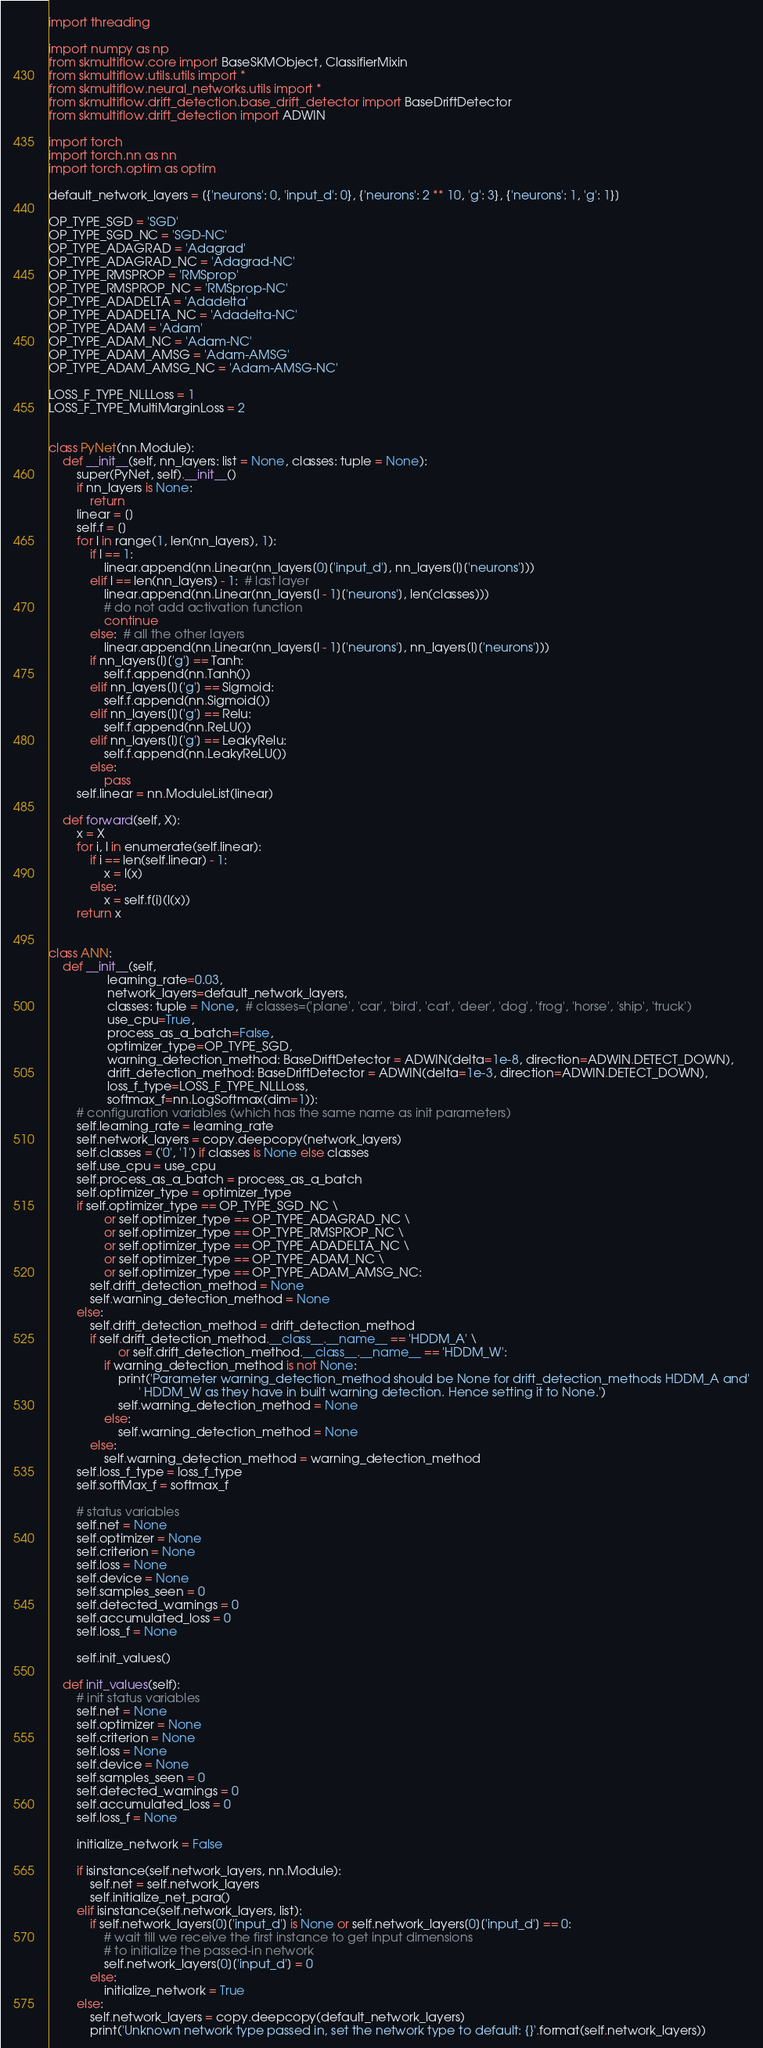Convert code to text. <code><loc_0><loc_0><loc_500><loc_500><_Python_>import threading

import numpy as np
from skmultiflow.core import BaseSKMObject, ClassifierMixin
from skmultiflow.utils.utils import *
from skmultiflow.neural_networks.utils import *
from skmultiflow.drift_detection.base_drift_detector import BaseDriftDetector
from skmultiflow.drift_detection import ADWIN

import torch
import torch.nn as nn
import torch.optim as optim

default_network_layers = [{'neurons': 0, 'input_d': 0}, {'neurons': 2 ** 10, 'g': 3}, {'neurons': 1, 'g': 1}]

OP_TYPE_SGD = 'SGD'
OP_TYPE_SGD_NC = 'SGD-NC'
OP_TYPE_ADAGRAD = 'Adagrad'
OP_TYPE_ADAGRAD_NC = 'Adagrad-NC'
OP_TYPE_RMSPROP = 'RMSprop'
OP_TYPE_RMSPROP_NC = 'RMSprop-NC'
OP_TYPE_ADADELTA = 'Adadelta'
OP_TYPE_ADADELTA_NC = 'Adadelta-NC'
OP_TYPE_ADAM = 'Adam'
OP_TYPE_ADAM_NC = 'Adam-NC'
OP_TYPE_ADAM_AMSG = 'Adam-AMSG'
OP_TYPE_ADAM_AMSG_NC = 'Adam-AMSG-NC'

LOSS_F_TYPE_NLLLoss = 1
LOSS_F_TYPE_MultiMarginLoss = 2


class PyNet(nn.Module):
    def __init__(self, nn_layers: list = None, classes: tuple = None):
        super(PyNet, self).__init__()
        if nn_layers is None:
            return
        linear = []
        self.f = []
        for l in range(1, len(nn_layers), 1):
            if l == 1:
                linear.append(nn.Linear(nn_layers[0]['input_d'], nn_layers[l]['neurons']))
            elif l == len(nn_layers) - 1:  # last layer
                linear.append(nn.Linear(nn_layers[l - 1]['neurons'], len(classes)))
                # do not add activation function
                continue
            else:  # all the other layers
                linear.append(nn.Linear(nn_layers[l - 1]['neurons'], nn_layers[l]['neurons']))
            if nn_layers[l]['g'] == Tanh:
                self.f.append(nn.Tanh())
            elif nn_layers[l]['g'] == Sigmoid:
                self.f.append(nn.Sigmoid())
            elif nn_layers[l]['g'] == Relu:
                self.f.append(nn.ReLU())
            elif nn_layers[l]['g'] == LeakyRelu:
                self.f.append(nn.LeakyReLU())
            else:
                pass
        self.linear = nn.ModuleList(linear)

    def forward(self, X):
        x = X
        for i, l in enumerate(self.linear):
            if i == len(self.linear) - 1:
                x = l(x)
            else:
                x = self.f[i](l(x))
        return x


class ANN:
    def __init__(self,
                 learning_rate=0.03,
                 network_layers=default_network_layers,
                 classes: tuple = None,  # classes=('plane', 'car', 'bird', 'cat', 'deer', 'dog', 'frog', 'horse', 'ship', 'truck')
                 use_cpu=True,
                 process_as_a_batch=False,
                 optimizer_type=OP_TYPE_SGD,
                 warning_detection_method: BaseDriftDetector = ADWIN(delta=1e-8, direction=ADWIN.DETECT_DOWN),
                 drift_detection_method: BaseDriftDetector = ADWIN(delta=1e-3, direction=ADWIN.DETECT_DOWN),
                 loss_f_type=LOSS_F_TYPE_NLLLoss,
                 softmax_f=nn.LogSoftmax(dim=1)):
        # configuration variables (which has the same name as init parameters)
        self.learning_rate = learning_rate
        self.network_layers = copy.deepcopy(network_layers)
        self.classes = ('0', '1') if classes is None else classes
        self.use_cpu = use_cpu
        self.process_as_a_batch = process_as_a_batch
        self.optimizer_type = optimizer_type
        if self.optimizer_type == OP_TYPE_SGD_NC \
                or self.optimizer_type == OP_TYPE_ADAGRAD_NC \
                or self.optimizer_type == OP_TYPE_RMSPROP_NC \
                or self.optimizer_type == OP_TYPE_ADADELTA_NC \
                or self.optimizer_type == OP_TYPE_ADAM_NC \
                or self.optimizer_type == OP_TYPE_ADAM_AMSG_NC:
            self.drift_detection_method = None
            self.warning_detection_method = None
        else:
            self.drift_detection_method = drift_detection_method
            if self.drift_detection_method.__class__.__name__ == 'HDDM_A' \
                    or self.drift_detection_method.__class__.__name__ == 'HDDM_W':
                if warning_detection_method is not None:
                    print('Parameter warning_detection_method should be None for drift_detection_methods HDDM_A and'
                          ' HDDM_W as they have in built warning detection. Hence setting it to None.')
                    self.warning_detection_method = None
                else:
                    self.warning_detection_method = None
            else:
                self.warning_detection_method = warning_detection_method
        self.loss_f_type = loss_f_type
        self.softMax_f = softmax_f

        # status variables
        self.net = None
        self.optimizer = None
        self.criterion = None
        self.loss = None
        self.device = None
        self.samples_seen = 0
        self.detected_warnings = 0
        self.accumulated_loss = 0
        self.loss_f = None

        self.init_values()

    def init_values(self):
        # init status variables
        self.net = None
        self.optimizer = None
        self.criterion = None
        self.loss = None
        self.device = None
        self.samples_seen = 0
        self.detected_warnings = 0
        self.accumulated_loss = 0
        self.loss_f = None

        initialize_network = False

        if isinstance(self.network_layers, nn.Module):
            self.net = self.network_layers
            self.initialize_net_para()
        elif isinstance(self.network_layers, list):
            if self.network_layers[0]['input_d'] is None or self.network_layers[0]['input_d'] == 0:
                # wait till we receive the first instance to get input dimensions
                # to initialize the passed-in network
                self.network_layers[0]['input_d'] = 0
            else:
                initialize_network = True
        else:
            self.network_layers = copy.deepcopy(default_network_layers)
            print('Unknown network type passed in, set the network type to default: {}'.format(self.network_layers))
</code> 